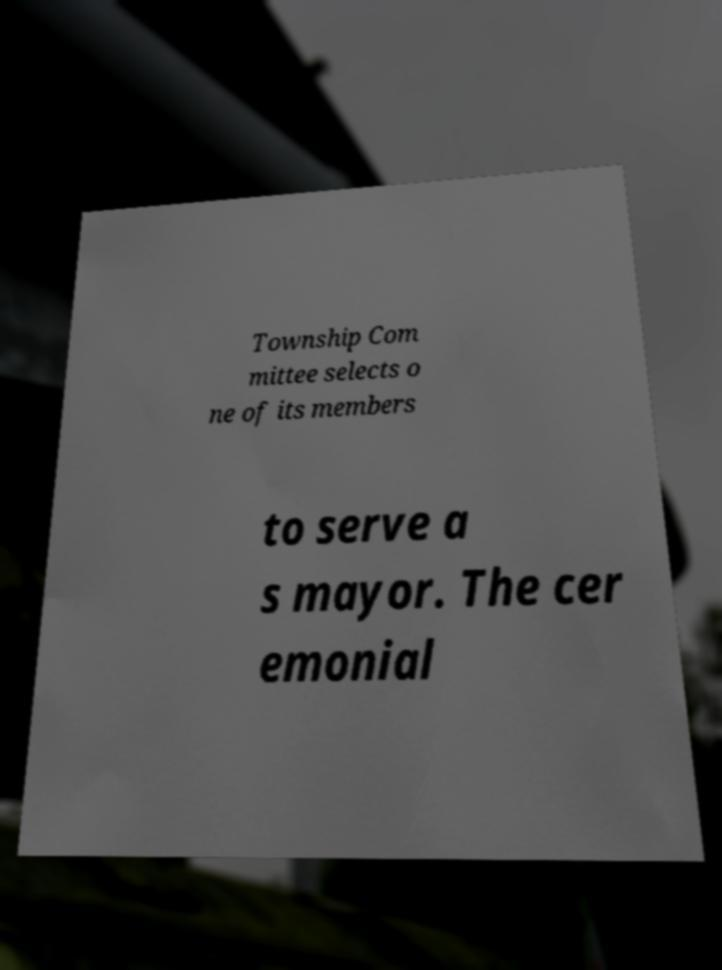Could you assist in decoding the text presented in this image and type it out clearly? Township Com mittee selects o ne of its members to serve a s mayor. The cer emonial 